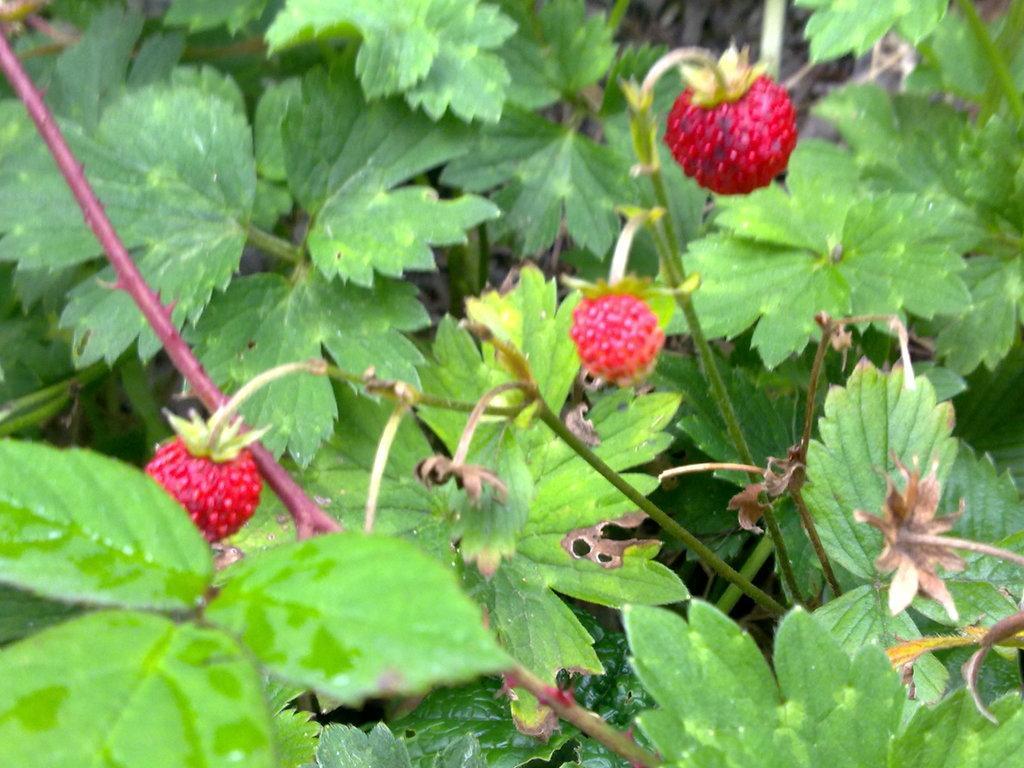How would you summarize this image in a sentence or two? In this picture we can see three red fruits and in the background we can see leaves. 